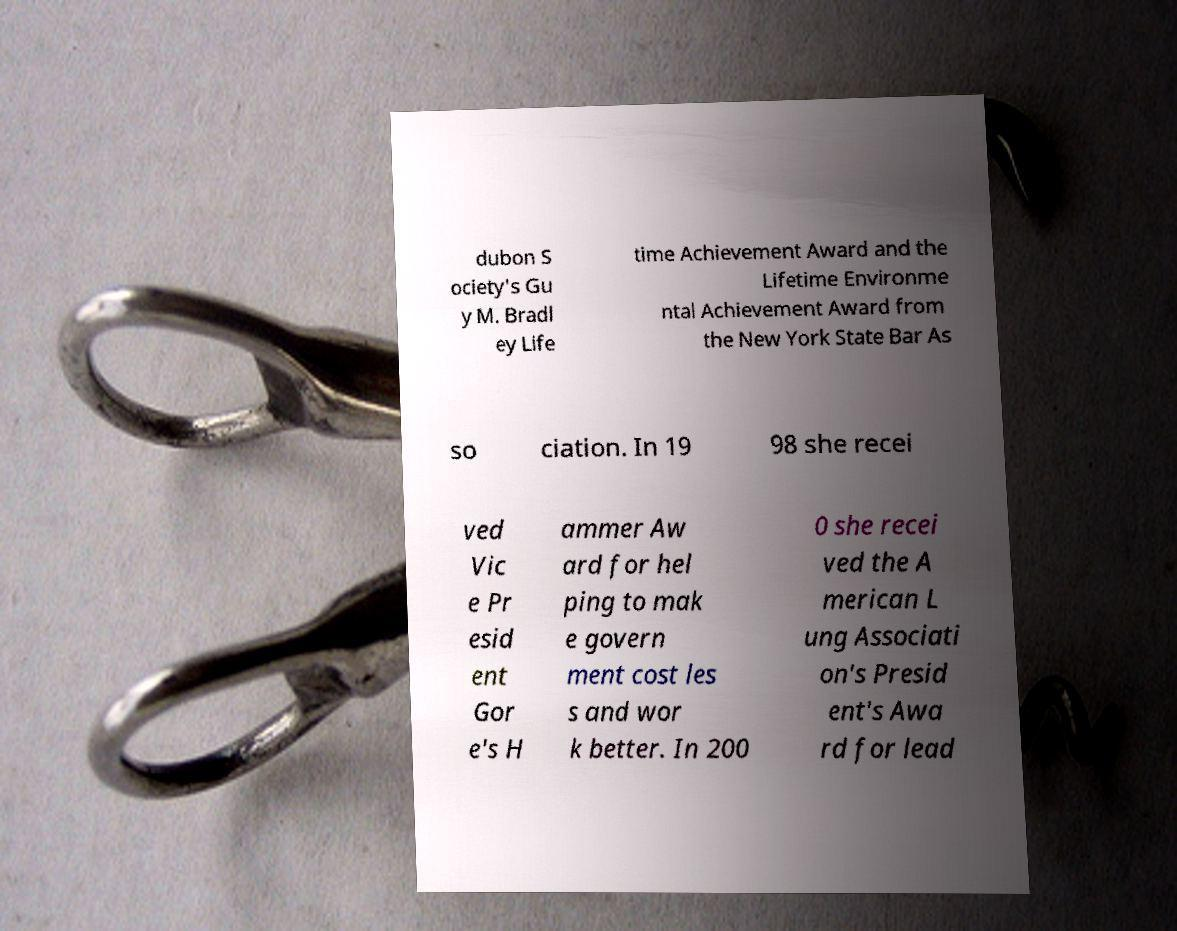Could you extract and type out the text from this image? dubon S ociety's Gu y M. Bradl ey Life time Achievement Award and the Lifetime Environme ntal Achievement Award from the New York State Bar As so ciation. In 19 98 she recei ved Vic e Pr esid ent Gor e's H ammer Aw ard for hel ping to mak e govern ment cost les s and wor k better. In 200 0 she recei ved the A merican L ung Associati on's Presid ent's Awa rd for lead 